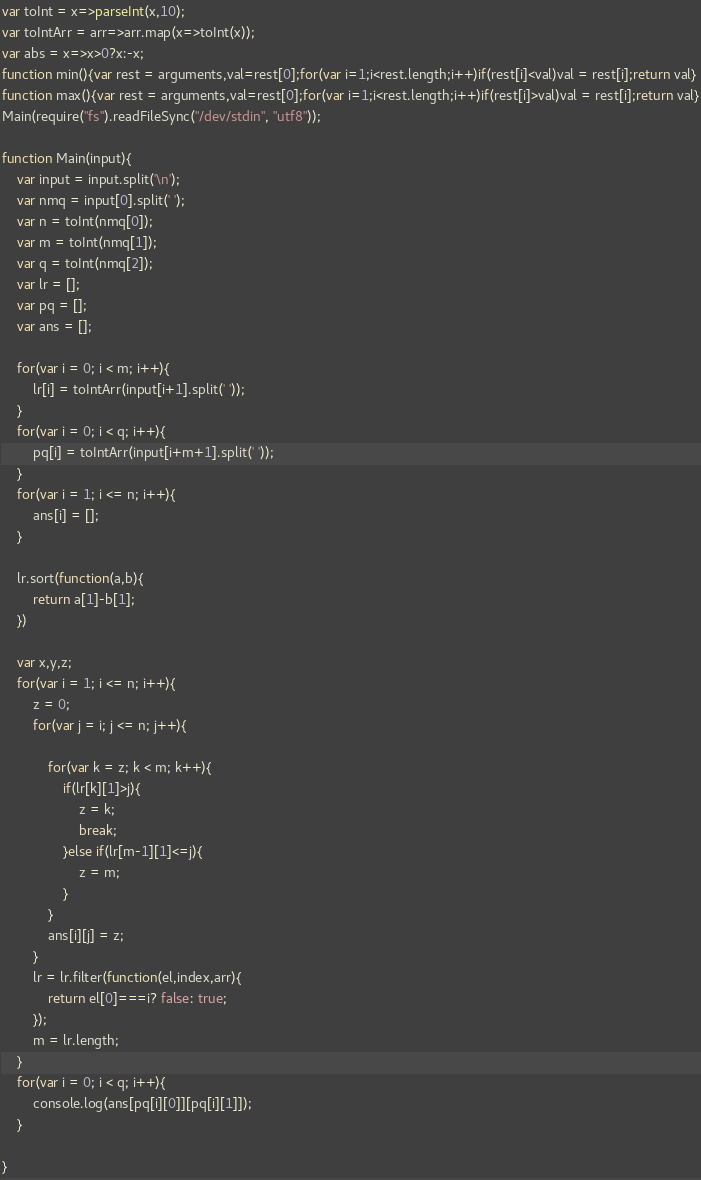Convert code to text. <code><loc_0><loc_0><loc_500><loc_500><_JavaScript_>var toInt = x=>parseInt(x,10);
var toIntArr = arr=>arr.map(x=>toInt(x));
var abs = x=>x>0?x:-x;
function min(){var rest = arguments,val=rest[0];for(var i=1;i<rest.length;i++)if(rest[i]<val)val = rest[i];return val}
function max(){var rest = arguments,val=rest[0];for(var i=1;i<rest.length;i++)if(rest[i]>val)val = rest[i];return val}
Main(require("fs").readFileSync("/dev/stdin", "utf8"));
 
function Main(input){
	var input = input.split('\n');
	var nmq = input[0].split(' ');
	var n = toInt(nmq[0]);
	var m = toInt(nmq[1]);
	var q = toInt(nmq[2]);
	var lr = [];
	var pq = [];
	var ans = [];

	for(var i = 0; i < m; i++){
		lr[i] = toIntArr(input[i+1].split(' '));
	}
	for(var i = 0; i < q; i++){
		pq[i] = toIntArr(input[i+m+1].split(' '));
	}
	for(var i = 1; i <= n; i++){
		ans[i] = [];
	}

	lr.sort(function(a,b){
		return a[1]-b[1];
	})

	var x,y,z;
	for(var i = 1; i <= n; i++){
		z = 0;
		for(var j = i; j <= n; j++){

			for(var k = z; k < m; k++){
				if(lr[k][1]>j){
					z = k;
					break;
				}else if(lr[m-1][1]<=j){
					z = m;
				}
			}
			ans[i][j] = z;
		}
		lr = lr.filter(function(el,index,arr){
			return el[0]===i? false: true;
		});
		m = lr.length;
	}
	for(var i = 0; i < q; i++){
		console.log(ans[pq[i][0]][pq[i][1]]);
	}

}</code> 